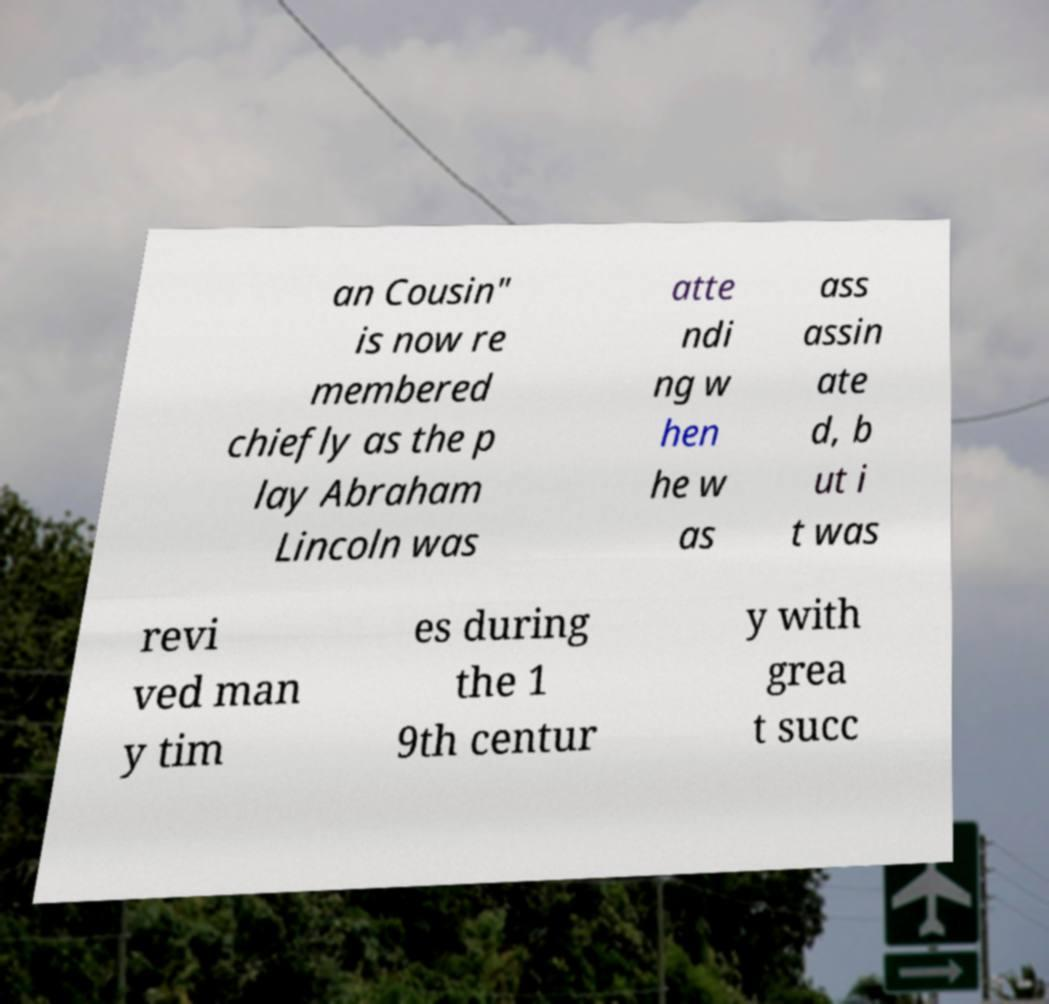I need the written content from this picture converted into text. Can you do that? an Cousin" is now re membered chiefly as the p lay Abraham Lincoln was atte ndi ng w hen he w as ass assin ate d, b ut i t was revi ved man y tim es during the 1 9th centur y with grea t succ 